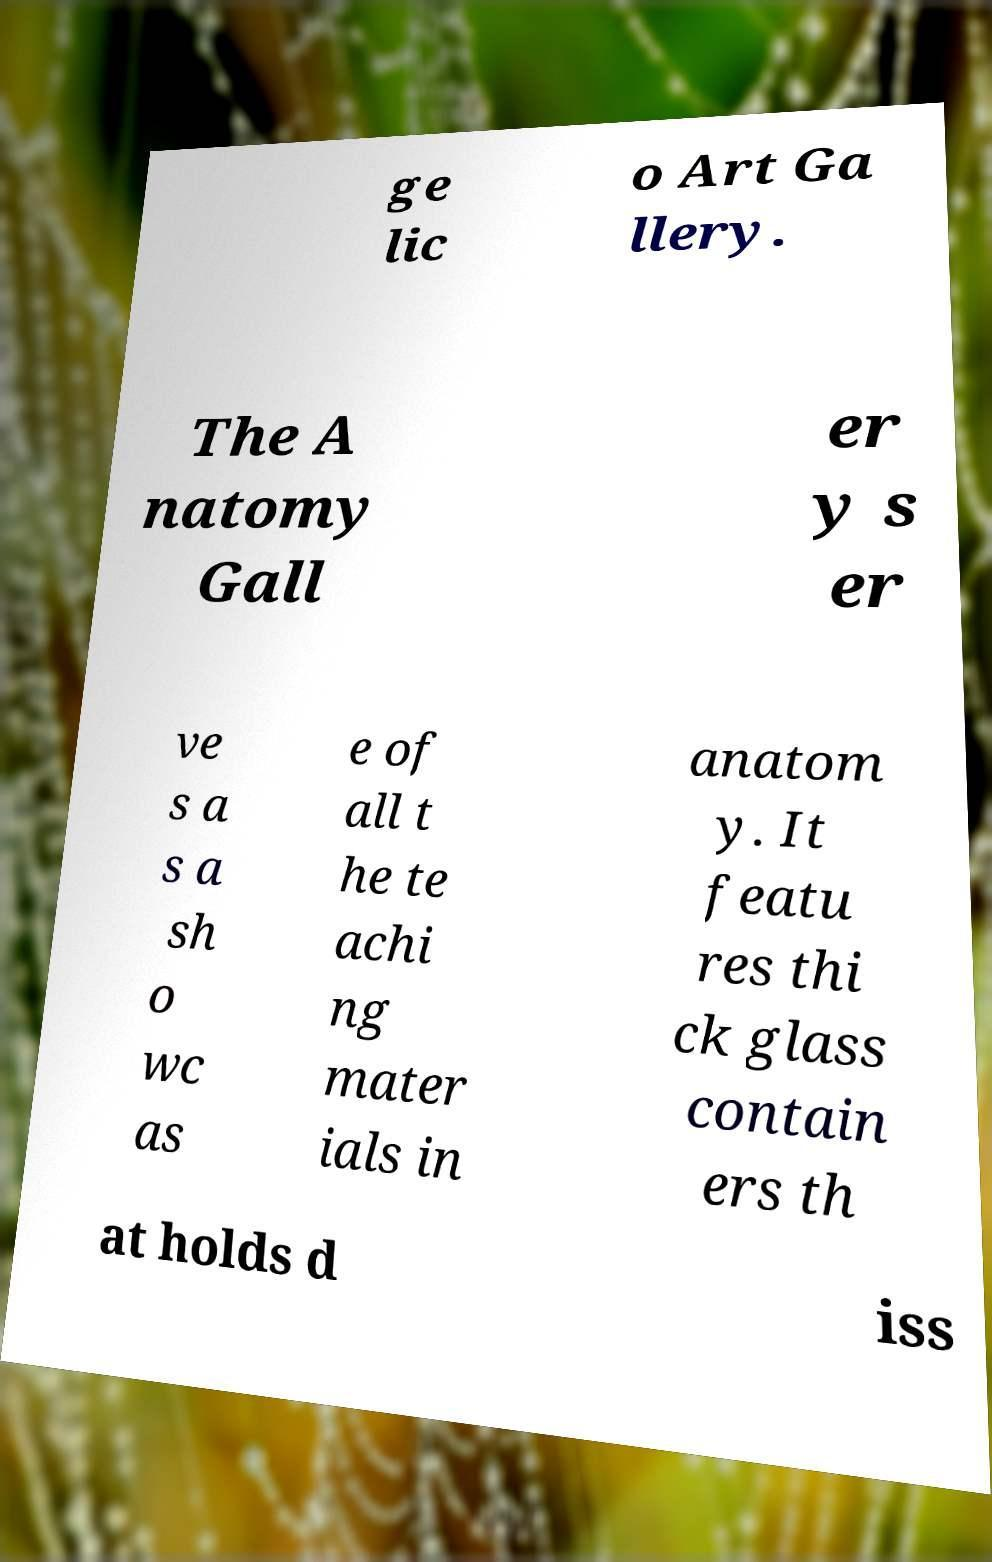I need the written content from this picture converted into text. Can you do that? ge lic o Art Ga llery. The A natomy Gall er y s er ve s a s a sh o wc as e of all t he te achi ng mater ials in anatom y. It featu res thi ck glass contain ers th at holds d iss 